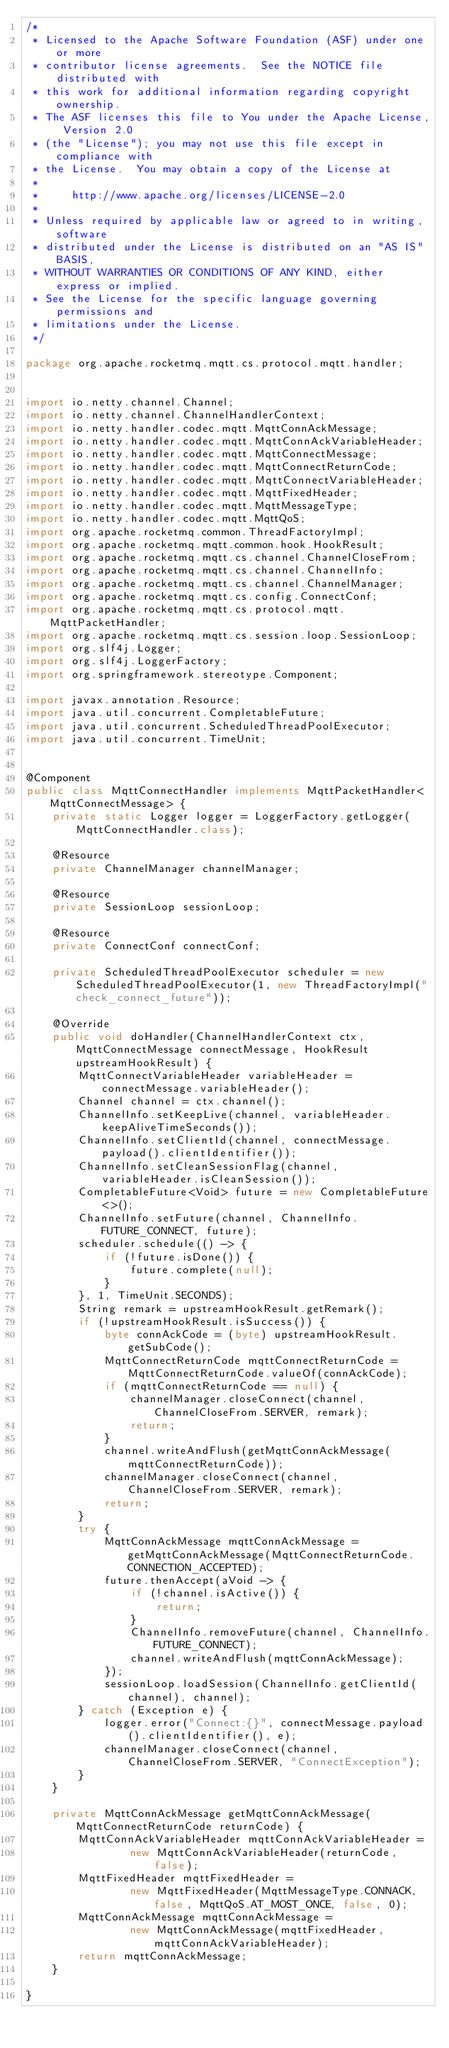<code> <loc_0><loc_0><loc_500><loc_500><_Java_>/*
 * Licensed to the Apache Software Foundation (ASF) under one or more
 * contributor license agreements.  See the NOTICE file distributed with
 * this work for additional information regarding copyright ownership.
 * The ASF licenses this file to You under the Apache License, Version 2.0
 * (the "License"); you may not use this file except in compliance with
 * the License.  You may obtain a copy of the License at
 *
 *     http://www.apache.org/licenses/LICENSE-2.0
 *
 * Unless required by applicable law or agreed to in writing, software
 * distributed under the License is distributed on an "AS IS" BASIS,
 * WITHOUT WARRANTIES OR CONDITIONS OF ANY KIND, either express or implied.
 * See the License for the specific language governing permissions and
 * limitations under the License.
 */

package org.apache.rocketmq.mqtt.cs.protocol.mqtt.handler;


import io.netty.channel.Channel;
import io.netty.channel.ChannelHandlerContext;
import io.netty.handler.codec.mqtt.MqttConnAckMessage;
import io.netty.handler.codec.mqtt.MqttConnAckVariableHeader;
import io.netty.handler.codec.mqtt.MqttConnectMessage;
import io.netty.handler.codec.mqtt.MqttConnectReturnCode;
import io.netty.handler.codec.mqtt.MqttConnectVariableHeader;
import io.netty.handler.codec.mqtt.MqttFixedHeader;
import io.netty.handler.codec.mqtt.MqttMessageType;
import io.netty.handler.codec.mqtt.MqttQoS;
import org.apache.rocketmq.common.ThreadFactoryImpl;
import org.apache.rocketmq.mqtt.common.hook.HookResult;
import org.apache.rocketmq.mqtt.cs.channel.ChannelCloseFrom;
import org.apache.rocketmq.mqtt.cs.channel.ChannelInfo;
import org.apache.rocketmq.mqtt.cs.channel.ChannelManager;
import org.apache.rocketmq.mqtt.cs.config.ConnectConf;
import org.apache.rocketmq.mqtt.cs.protocol.mqtt.MqttPacketHandler;
import org.apache.rocketmq.mqtt.cs.session.loop.SessionLoop;
import org.slf4j.Logger;
import org.slf4j.LoggerFactory;
import org.springframework.stereotype.Component;

import javax.annotation.Resource;
import java.util.concurrent.CompletableFuture;
import java.util.concurrent.ScheduledThreadPoolExecutor;
import java.util.concurrent.TimeUnit;


@Component
public class MqttConnectHandler implements MqttPacketHandler<MqttConnectMessage> {
    private static Logger logger = LoggerFactory.getLogger(MqttConnectHandler.class);

    @Resource
    private ChannelManager channelManager;

    @Resource
    private SessionLoop sessionLoop;

    @Resource
    private ConnectConf connectConf;

    private ScheduledThreadPoolExecutor scheduler = new ScheduledThreadPoolExecutor(1, new ThreadFactoryImpl("check_connect_future"));

    @Override
    public void doHandler(ChannelHandlerContext ctx, MqttConnectMessage connectMessage, HookResult upstreamHookResult) {
        MqttConnectVariableHeader variableHeader = connectMessage.variableHeader();
        Channel channel = ctx.channel();
        ChannelInfo.setKeepLive(channel, variableHeader.keepAliveTimeSeconds());
        ChannelInfo.setClientId(channel, connectMessage.payload().clientIdentifier());
        ChannelInfo.setCleanSessionFlag(channel, variableHeader.isCleanSession());
        CompletableFuture<Void> future = new CompletableFuture<>();
        ChannelInfo.setFuture(channel, ChannelInfo.FUTURE_CONNECT, future);
        scheduler.schedule(() -> {
            if (!future.isDone()) {
                future.complete(null);
            }
        }, 1, TimeUnit.SECONDS);
        String remark = upstreamHookResult.getRemark();
        if (!upstreamHookResult.isSuccess()) {
            byte connAckCode = (byte) upstreamHookResult.getSubCode();
            MqttConnectReturnCode mqttConnectReturnCode = MqttConnectReturnCode.valueOf(connAckCode);
            if (mqttConnectReturnCode == null) {
                channelManager.closeConnect(channel, ChannelCloseFrom.SERVER, remark);
                return;
            }
            channel.writeAndFlush(getMqttConnAckMessage(mqttConnectReturnCode));
            channelManager.closeConnect(channel, ChannelCloseFrom.SERVER, remark);
            return;
        }
        try {
            MqttConnAckMessage mqttConnAckMessage = getMqttConnAckMessage(MqttConnectReturnCode.CONNECTION_ACCEPTED);
            future.thenAccept(aVoid -> {
                if (!channel.isActive()) {
                    return;
                }
                ChannelInfo.removeFuture(channel, ChannelInfo.FUTURE_CONNECT);
                channel.writeAndFlush(mqttConnAckMessage);
            });
            sessionLoop.loadSession(ChannelInfo.getClientId(channel), channel);
        } catch (Exception e) {
            logger.error("Connect:{}", connectMessage.payload().clientIdentifier(), e);
            channelManager.closeConnect(channel, ChannelCloseFrom.SERVER, "ConnectException");
        }
    }

    private MqttConnAckMessage getMqttConnAckMessage(MqttConnectReturnCode returnCode) {
        MqttConnAckVariableHeader mqttConnAckVariableHeader =
                new MqttConnAckVariableHeader(returnCode, false);
        MqttFixedHeader mqttFixedHeader =
                new MqttFixedHeader(MqttMessageType.CONNACK, false, MqttQoS.AT_MOST_ONCE, false, 0);
        MqttConnAckMessage mqttConnAckMessage =
                new MqttConnAckMessage(mqttFixedHeader, mqttConnAckVariableHeader);
        return mqttConnAckMessage;
    }

}
</code> 